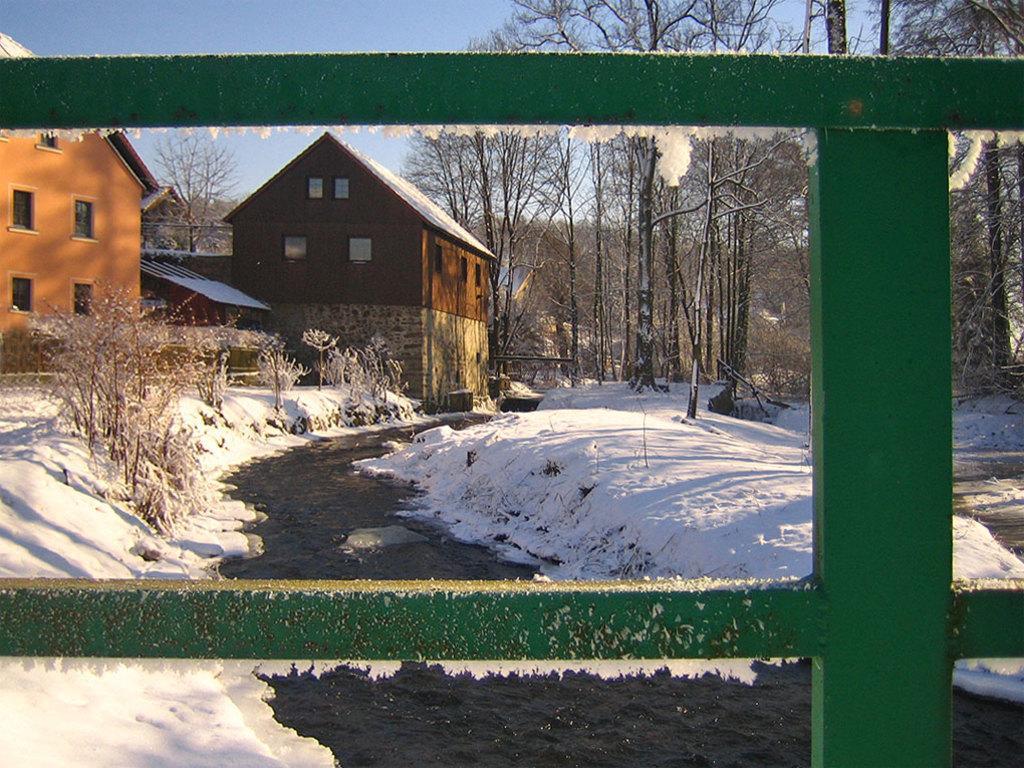In one or two sentences, can you explain what this image depicts? In this picture there is a window in foreground of the image, from which we can see, there are houses, plants, and trees, which are covered with snow and there is snow in the center of the image. 